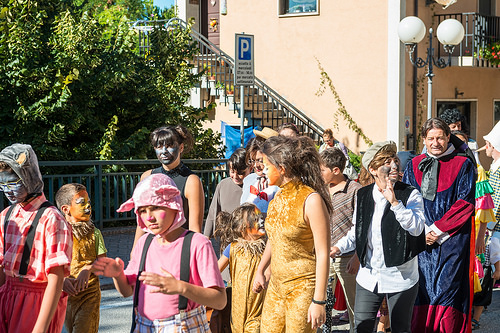<image>
Is there a sign in front of the person? No. The sign is not in front of the person. The spatial positioning shows a different relationship between these objects. 